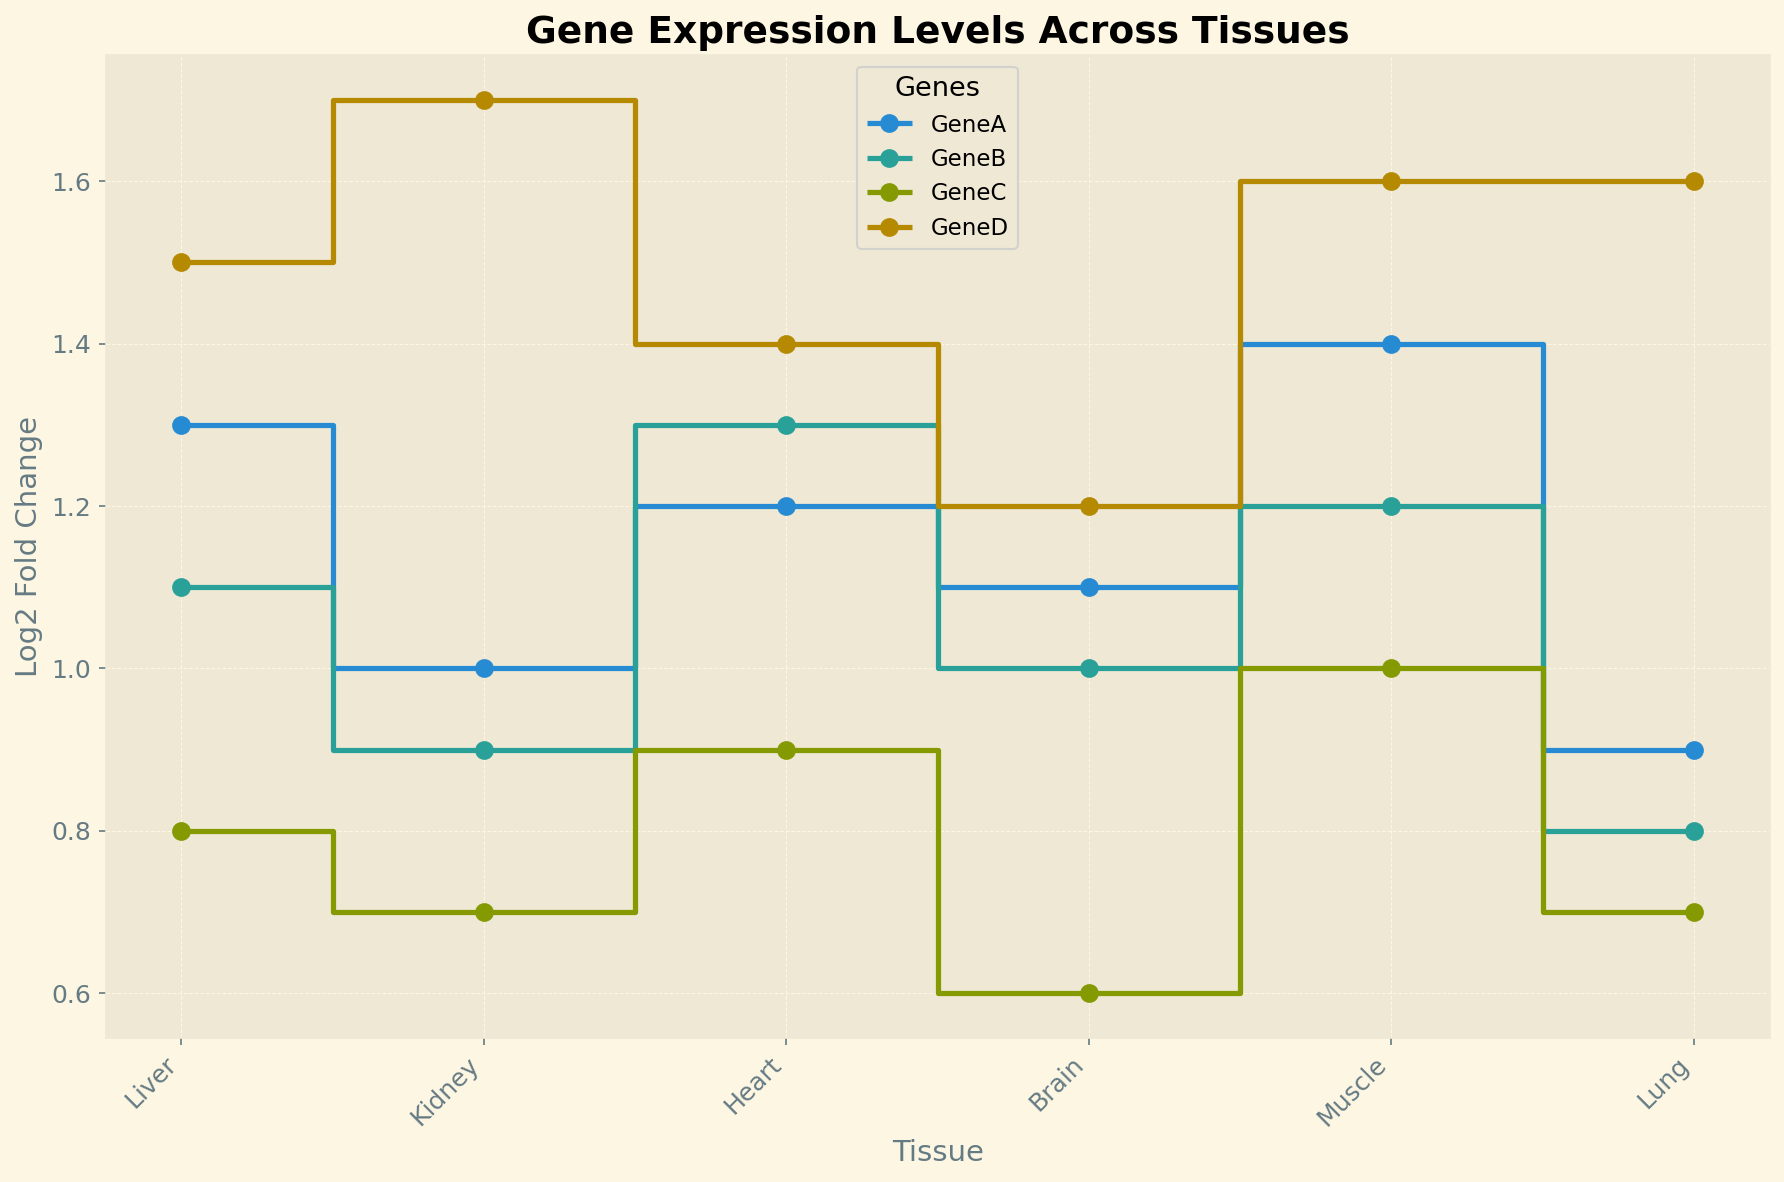Which gene shows the highest Log2 Fold Change in Muscle tissue? Look at the Muscle tissue section and identify the highest y-axis value. Gene D shows the highest point with a Log2 Fold Change of 1.6.
Answer: Gene D Which tissue has the lowest Log2 Fold Change for Gene B? Check each tissue for the Log2 Fold Change of Gene B and find the minimum value. It is found in Lung with a value of 0.8.
Answer: Lung What's the average Log2 Fold Change of Gene A across all tissues? Sum the Log2 Fold Changes for Gene A across all tissues and divide by the number of tissues. The values are 1.3, 1.0, 1.2, 1.1, 1.4, and 0.9. Adding these, we get 6.9. Dividing by 6 tissues gives 6.9/6 = 1.15.
Answer: 1.15 Compare the Log2 Fold Change of Gene C between Liver and Brain tissues. Which tissue has a higher value? Compare the Log2 Fold Change of Gene C in Liver (0.8) and Brain (0.6). Liver has a higher value.
Answer: Liver In terms of Log2 Fold Change, which gene shows the most variation across tissues? Evaluate the range (max-min) of Log2 Fold Change for each gene across all tissues: Gene A (1.4-0.9=0.5), Gene B (1.3-0.8=0.5), Gene C (1.0-0.6=0.4), Gene D (1.7-1.2=0.5). Gene D shows the most variation.
Answer: Gene D Which tissue shows the smallest variation in Log2 Fold Change among all genes? Check the Log2 Fold Change values for all genes within each tissue and find the one with the smallest range. Brain (1.2-1.0=0.2) has the smallest range.
Answer: Brain For Gene D, how much greater is the Log2 Fold Change in Kidney compared to Brain? Subtract the Log2 Fold Change of Gene D in Brain from its value in Kidney. Kidney (1.7) - Brain (1.2) = 0.5.
Answer: 0.5 Is there a tissue where the Log2 Fold Change of all genes is greater than 1? If so, which tissue? Check each tissue to see if Log2 Fold Change is greater than 1 for all genes. Muscle meets this condition with values 1.4, 1.2, 1.0, and 1.6.
Answer: Muscle Which gene has the most consistent Log2 Fold Change across different tissues? Calculate the standard deviation of Log2 Fold Change for each gene. The one with the smallest standard deviation is the most consistent. Gene C shows almost no variation with values around 0.7-1.0.
Answer: Gene C 